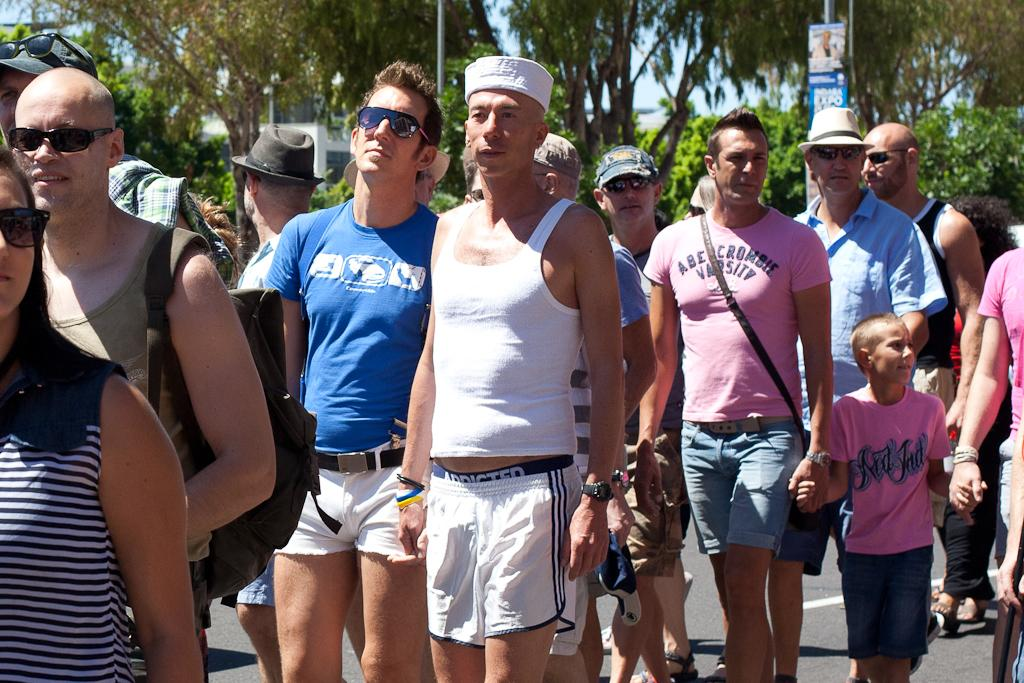<image>
Share a concise interpretation of the image provided. A man in an Abercrombie shirt holds hands with a young boy in a pink shirt. 